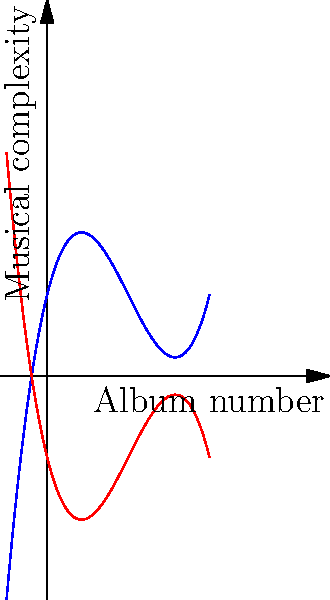The blue curve represents Peter Lemongello's musical style evolution across his albums, described by the function $f(x) = 0.5x^3 - 3x^2 + 4x + 2$, where $x$ is the album number. If his style undergoes a transformation represented by $g(x) = -f(x)$, which is shown by the red curve, what is the new function $g(x)$ in expanded form? To find the new function $g(x)$, we need to apply the transformation $g(x) = -f(x)$ to the original function. Let's do this step-by-step:

1) The original function is $f(x) = 0.5x^3 - 3x^2 + 4x + 2$

2) To get $g(x)$, we multiply every term of $f(x)$ by $-1$:

   $g(x) = -f(x)$
   $g(x) = -(0.5x^3 - 3x^2 + 4x + 2)$

3) Distributing the negative sign:

   $g(x) = -0.5x^3 + 3x^2 - 4x - 2$

This resulting function represents the transformed musical style of Peter Lemongello across his albums.
Answer: $g(x) = -0.5x^3 + 3x^2 - 4x - 2$ 